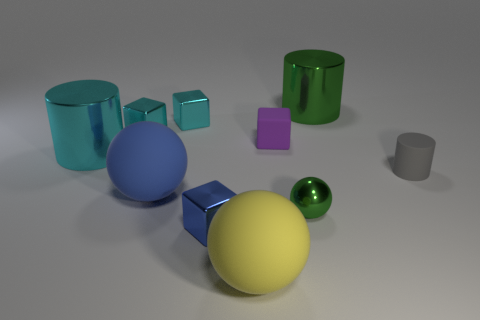What can you infer about the shapes present in the image? There's a variety of geometric shapes. The sphere, cube, and cylinder are fundamental 3D shapes, often used in educational contexts to teach geometry. Their presence alongside irregular prisms (like the green glass objects) indicates a study of form and dimensionality, possibly in an artistic or instructional setting. 